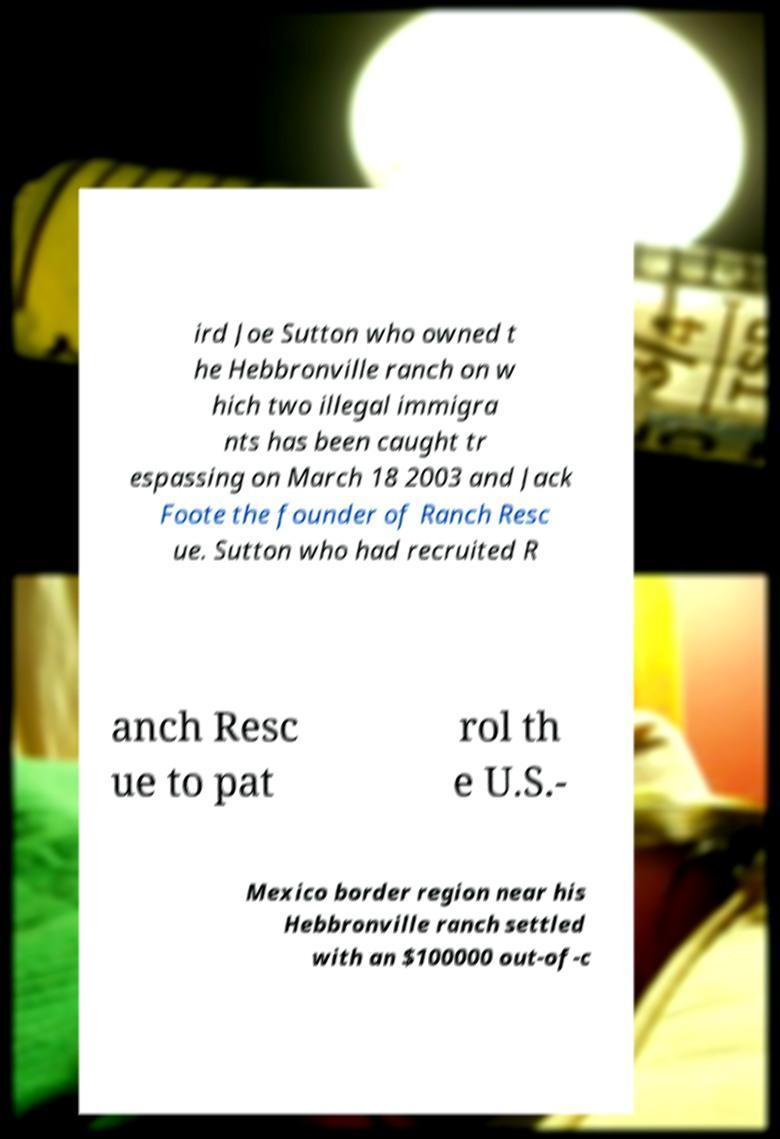Could you assist in decoding the text presented in this image and type it out clearly? ird Joe Sutton who owned t he Hebbronville ranch on w hich two illegal immigra nts has been caught tr espassing on March 18 2003 and Jack Foote the founder of Ranch Resc ue. Sutton who had recruited R anch Resc ue to pat rol th e U.S.- Mexico border region near his Hebbronville ranch settled with an $100000 out-of-c 